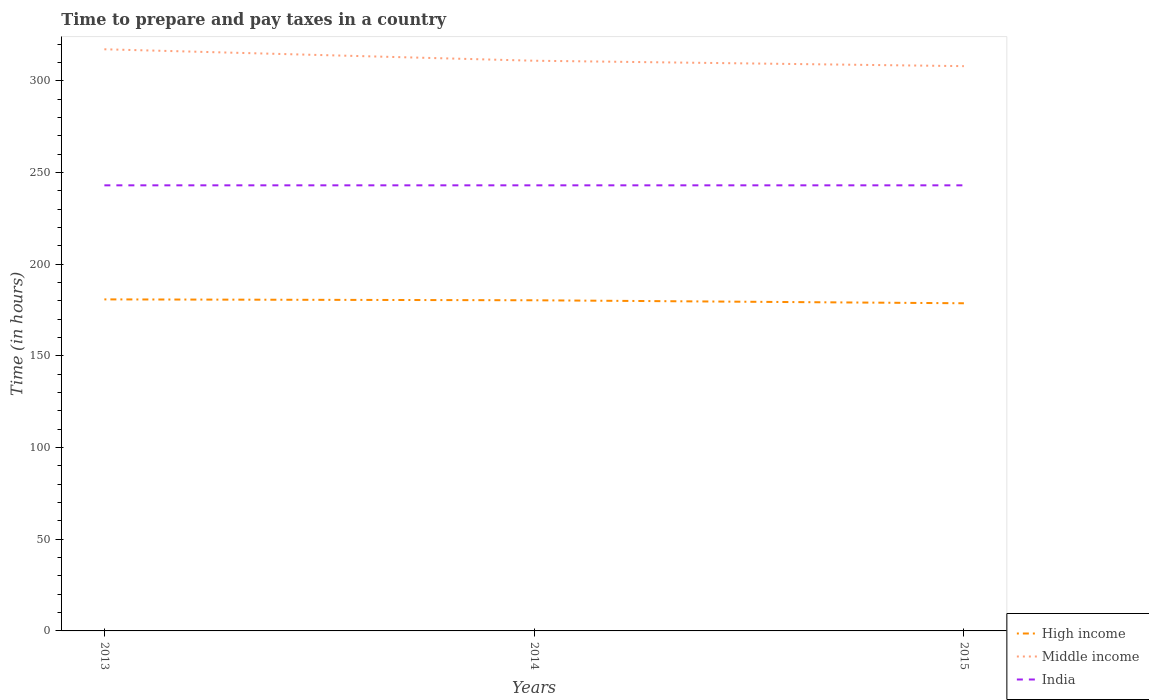How many different coloured lines are there?
Provide a short and direct response. 3. Does the line corresponding to Middle income intersect with the line corresponding to High income?
Keep it short and to the point. No. Is the number of lines equal to the number of legend labels?
Provide a succinct answer. Yes. Across all years, what is the maximum number of hours required to prepare and pay taxes in High income?
Your answer should be very brief. 178.68. What is the total number of hours required to prepare and pay taxes in India in the graph?
Provide a short and direct response. 0. What is the difference between the highest and the second highest number of hours required to prepare and pay taxes in Middle income?
Make the answer very short. 9.2. What is the difference between the highest and the lowest number of hours required to prepare and pay taxes in India?
Ensure brevity in your answer.  0. How many lines are there?
Offer a very short reply. 3. Does the graph contain grids?
Make the answer very short. No. How many legend labels are there?
Provide a succinct answer. 3. What is the title of the graph?
Provide a succinct answer. Time to prepare and pay taxes in a country. What is the label or title of the X-axis?
Provide a short and direct response. Years. What is the label or title of the Y-axis?
Keep it short and to the point. Time (in hours). What is the Time (in hours) in High income in 2013?
Make the answer very short. 180.8. What is the Time (in hours) of Middle income in 2013?
Offer a terse response. 317.19. What is the Time (in hours) in India in 2013?
Offer a terse response. 243. What is the Time (in hours) in High income in 2014?
Your answer should be very brief. 180.32. What is the Time (in hours) in Middle income in 2014?
Provide a succinct answer. 310.95. What is the Time (in hours) in India in 2014?
Keep it short and to the point. 243. What is the Time (in hours) in High income in 2015?
Provide a short and direct response. 178.68. What is the Time (in hours) in Middle income in 2015?
Your answer should be compact. 308. What is the Time (in hours) in India in 2015?
Offer a very short reply. 243. Across all years, what is the maximum Time (in hours) in High income?
Ensure brevity in your answer.  180.8. Across all years, what is the maximum Time (in hours) of Middle income?
Offer a terse response. 317.19. Across all years, what is the maximum Time (in hours) of India?
Your answer should be very brief. 243. Across all years, what is the minimum Time (in hours) in High income?
Provide a succinct answer. 178.68. Across all years, what is the minimum Time (in hours) in Middle income?
Your answer should be very brief. 308. Across all years, what is the minimum Time (in hours) of India?
Make the answer very short. 243. What is the total Time (in hours) of High income in the graph?
Your response must be concise. 539.8. What is the total Time (in hours) in Middle income in the graph?
Offer a terse response. 936.14. What is the total Time (in hours) of India in the graph?
Ensure brevity in your answer.  729. What is the difference between the Time (in hours) in High income in 2013 and that in 2014?
Make the answer very short. 0.48. What is the difference between the Time (in hours) in Middle income in 2013 and that in 2014?
Your answer should be very brief. 6.25. What is the difference between the Time (in hours) in High income in 2013 and that in 2015?
Offer a terse response. 2.12. What is the difference between the Time (in hours) in Middle income in 2013 and that in 2015?
Give a very brief answer. 9.2. What is the difference between the Time (in hours) of India in 2013 and that in 2015?
Provide a short and direct response. 0. What is the difference between the Time (in hours) in High income in 2014 and that in 2015?
Provide a succinct answer. 1.63. What is the difference between the Time (in hours) in Middle income in 2014 and that in 2015?
Give a very brief answer. 2.95. What is the difference between the Time (in hours) in High income in 2013 and the Time (in hours) in Middle income in 2014?
Offer a very short reply. -130.15. What is the difference between the Time (in hours) in High income in 2013 and the Time (in hours) in India in 2014?
Give a very brief answer. -62.2. What is the difference between the Time (in hours) of Middle income in 2013 and the Time (in hours) of India in 2014?
Offer a very short reply. 74.19. What is the difference between the Time (in hours) in High income in 2013 and the Time (in hours) in Middle income in 2015?
Your response must be concise. -127.2. What is the difference between the Time (in hours) of High income in 2013 and the Time (in hours) of India in 2015?
Ensure brevity in your answer.  -62.2. What is the difference between the Time (in hours) in Middle income in 2013 and the Time (in hours) in India in 2015?
Your response must be concise. 74.19. What is the difference between the Time (in hours) of High income in 2014 and the Time (in hours) of Middle income in 2015?
Provide a succinct answer. -127.68. What is the difference between the Time (in hours) of High income in 2014 and the Time (in hours) of India in 2015?
Keep it short and to the point. -62.68. What is the difference between the Time (in hours) of Middle income in 2014 and the Time (in hours) of India in 2015?
Make the answer very short. 67.95. What is the average Time (in hours) in High income per year?
Offer a terse response. 179.93. What is the average Time (in hours) of Middle income per year?
Your response must be concise. 312.05. What is the average Time (in hours) of India per year?
Your answer should be compact. 243. In the year 2013, what is the difference between the Time (in hours) in High income and Time (in hours) in Middle income?
Provide a short and direct response. -136.39. In the year 2013, what is the difference between the Time (in hours) in High income and Time (in hours) in India?
Keep it short and to the point. -62.2. In the year 2013, what is the difference between the Time (in hours) of Middle income and Time (in hours) of India?
Your response must be concise. 74.19. In the year 2014, what is the difference between the Time (in hours) of High income and Time (in hours) of Middle income?
Your response must be concise. -130.63. In the year 2014, what is the difference between the Time (in hours) in High income and Time (in hours) in India?
Your answer should be compact. -62.68. In the year 2014, what is the difference between the Time (in hours) of Middle income and Time (in hours) of India?
Offer a terse response. 67.95. In the year 2015, what is the difference between the Time (in hours) of High income and Time (in hours) of Middle income?
Ensure brevity in your answer.  -129.31. In the year 2015, what is the difference between the Time (in hours) in High income and Time (in hours) in India?
Your response must be concise. -64.32. In the year 2015, what is the difference between the Time (in hours) of Middle income and Time (in hours) of India?
Ensure brevity in your answer.  65. What is the ratio of the Time (in hours) of Middle income in 2013 to that in 2014?
Provide a succinct answer. 1.02. What is the ratio of the Time (in hours) in High income in 2013 to that in 2015?
Your answer should be very brief. 1.01. What is the ratio of the Time (in hours) of Middle income in 2013 to that in 2015?
Your response must be concise. 1.03. What is the ratio of the Time (in hours) of High income in 2014 to that in 2015?
Your answer should be compact. 1.01. What is the ratio of the Time (in hours) in Middle income in 2014 to that in 2015?
Keep it short and to the point. 1.01. What is the difference between the highest and the second highest Time (in hours) in High income?
Provide a succinct answer. 0.48. What is the difference between the highest and the second highest Time (in hours) of Middle income?
Your response must be concise. 6.25. What is the difference between the highest and the second highest Time (in hours) in India?
Keep it short and to the point. 0. What is the difference between the highest and the lowest Time (in hours) in High income?
Offer a terse response. 2.12. What is the difference between the highest and the lowest Time (in hours) of Middle income?
Your response must be concise. 9.2. What is the difference between the highest and the lowest Time (in hours) of India?
Your answer should be very brief. 0. 